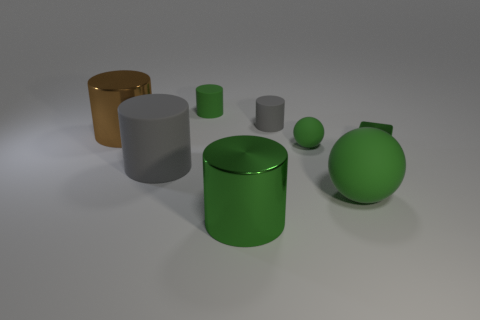How many objects are there in total, and can you describe their shapes and colors? There are six objects in total, comprising two cylinders, one sphere, one cube, and two toruses. The large cylinder and the sphere are green, the cube and one torus are brown, and the small cylinder and the other torus are grey. 